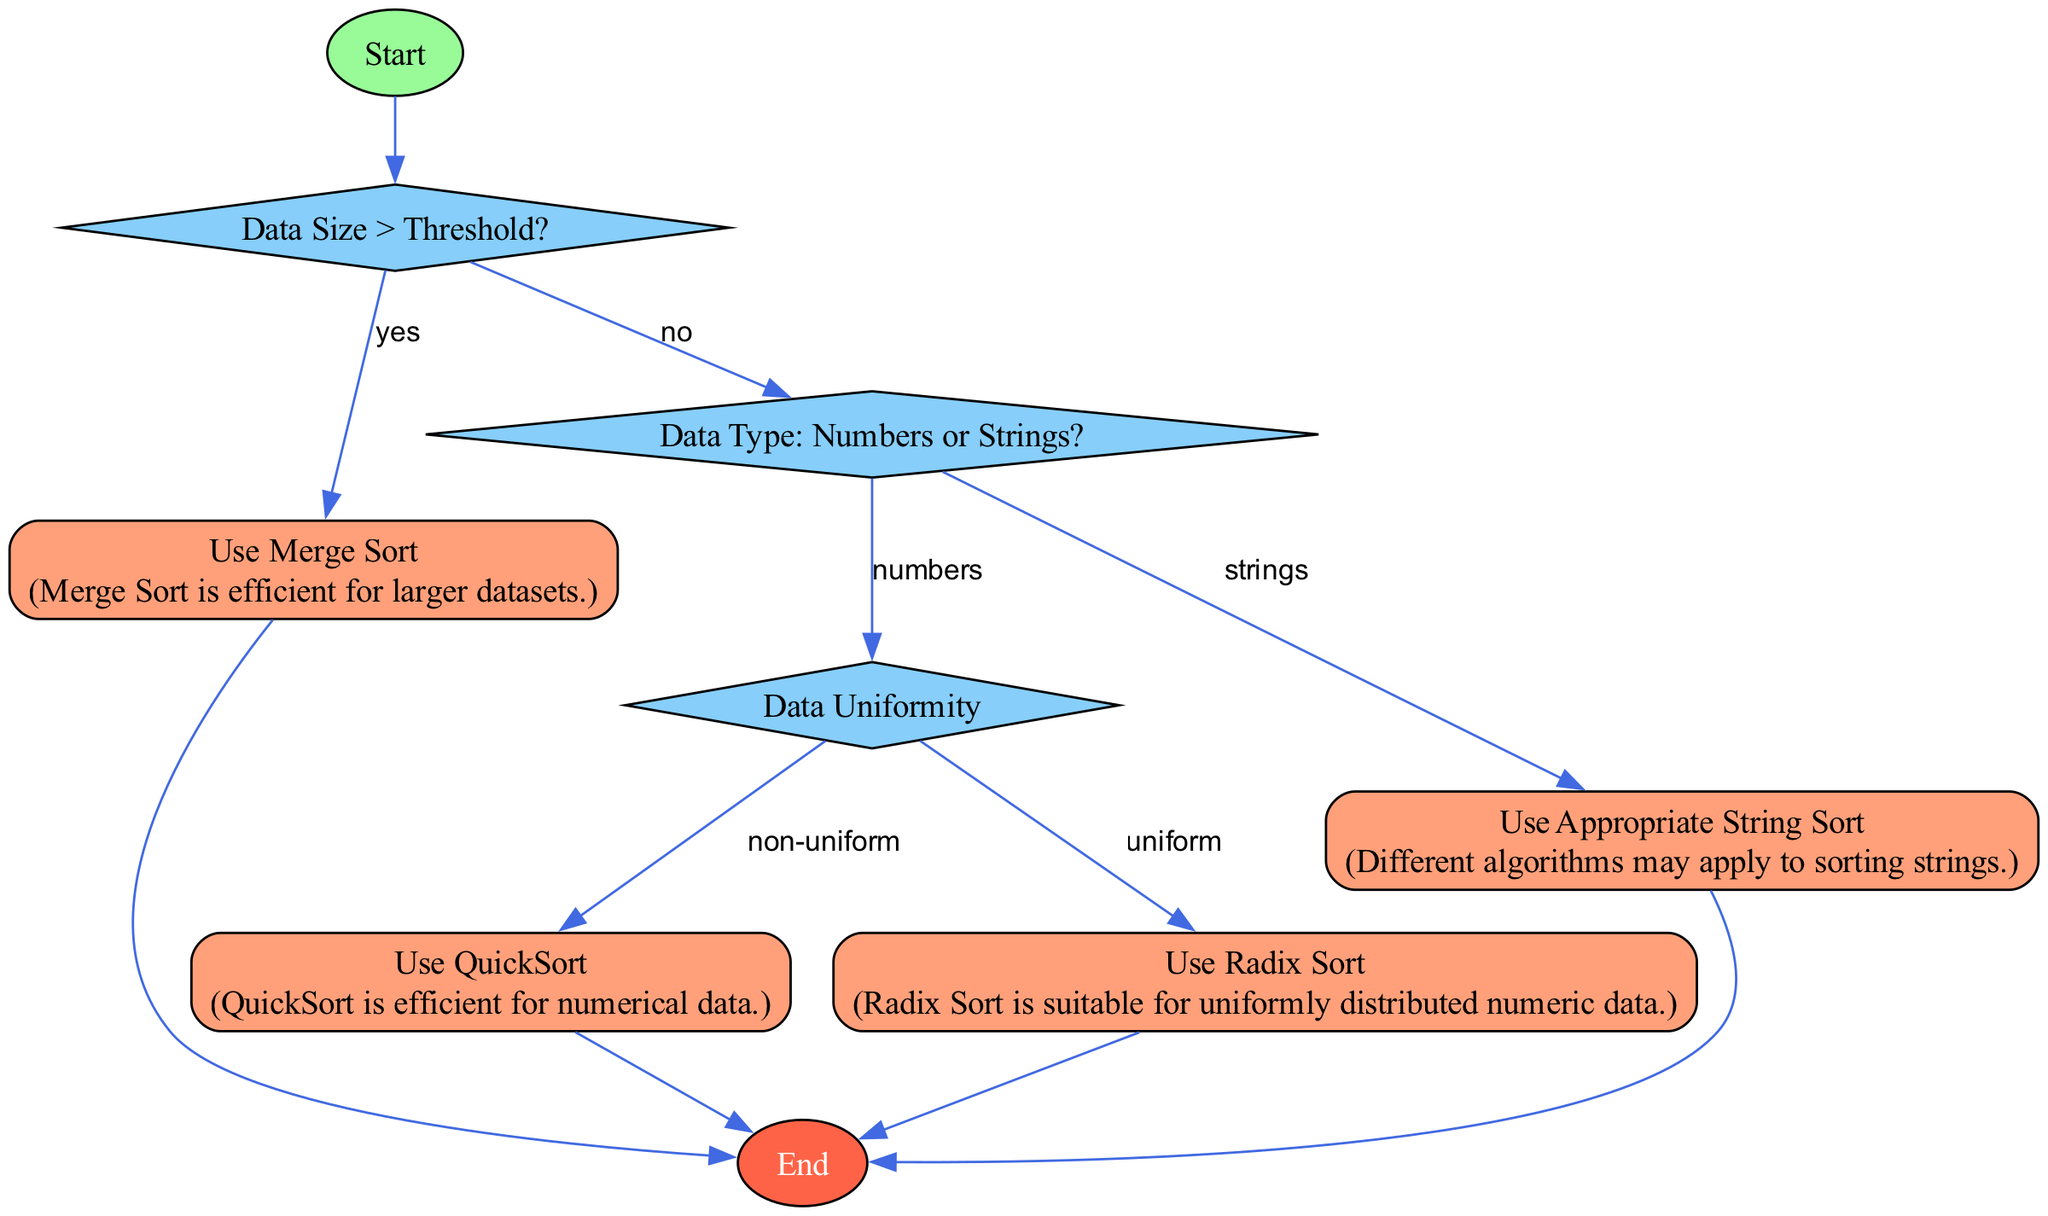What is the first node in the flowchart? The first node in the flowchart is labeled "Start." It is the initial point from which the decision-making process begins.
Answer: Start How many decision nodes are there in total? There are three decision nodes: one for checking data size, one for checking data type, and one for checking data uniformity. Each decision node determines the path to follow based on the answers provided.
Answer: 3 What process is recommended if the data size is larger than the threshold? If the data size is larger than the threshold, the flowchart directs to the process labeled "Use Merge Sort," which is designed for larger datasets.
Answer: Use Merge Sort What happens if the data type is identified as strings? If the data type is identified as strings, the flowchart directs to the process labeled "Use Appropriate String Sort." This step indicates that specific algorithms may be applied when sorting strings.
Answer: Use Appropriate String Sort Which sorting algorithm is suggested for uniformly distributed numeric data? The sorting algorithm suggested for uniformly distributed numeric data is "Use Radix Sort," indicating that this algorithm is particularly suited for such data distributions.
Answer: Use Radix Sort After using QuickSort for non-uniform numeric data, where does the flowchart lead? After using QuickSort for non-uniform numeric data, the flowchart leads to the "End" node, indicating the conclusion of the sorting process.
Answer: End If the data size is not greater than the threshold, what is the next decision node? If the data size is not greater than the threshold, the next decision node to evaluate is "Data Type: Numbers or Strings?" which determines whether to process as numbers or strings based on the data type.
Answer: Data Type: Numbers or Strings? What is the information provided in the "Use QuickSort" process? The information provided for "Use QuickSort" states that "QuickSort is efficient for numerical data." This highlights the suitability of the QuickSort algorithm when processing numbers as the data type.
Answer: QuickSort is efficient for numerical data 